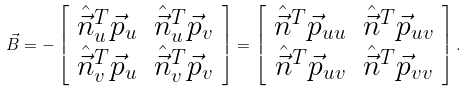Convert formula to latex. <formula><loc_0><loc_0><loc_500><loc_500>\vec { B } = - \left [ \begin{array} { c c } \hat { \vec { n } } _ { u } ^ { T } \vec { p } _ { u } & \hat { \vec { n } } _ { u } ^ { T } \vec { p } _ { v } \\ \hat { \vec { n } } _ { v } ^ { T } \vec { p } _ { u } & \hat { \vec { n } } _ { v } ^ { T } \vec { p } _ { v } \end{array} \right ] = \left [ \begin{array} { c c } \hat { \vec { n } } ^ { T } \vec { p } _ { u u } & \hat { \vec { n } } ^ { T } \vec { p } _ { u v } \\ \hat { \vec { n } } ^ { T } \vec { p } _ { u v } & \hat { \vec { n } } ^ { T } \vec { p } _ { v v } \end{array} \right ] .</formula> 